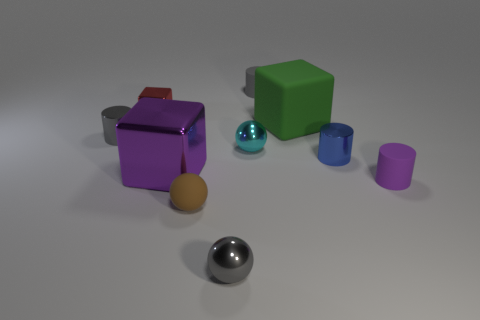There is another metal thing that is the same shape as the small red object; what is its size?
Offer a very short reply. Large. There is a purple rubber cylinder; does it have the same size as the green matte block that is right of the big purple metal block?
Your answer should be compact. No. The purple rubber thing that is right of the big metallic block has what shape?
Your answer should be very brief. Cylinder. The small shiny cylinder that is to the right of the metallic cylinder that is on the left side of the green matte thing is what color?
Offer a terse response. Blue. The other matte object that is the same shape as the tiny red thing is what color?
Your response must be concise. Green. What number of tiny metal balls are the same color as the big matte object?
Ensure brevity in your answer.  0. Is the color of the large metallic object the same as the small object that is on the right side of the small blue metallic thing?
Your answer should be compact. Yes. The gray object that is both behind the purple rubber cylinder and right of the big shiny thing has what shape?
Make the answer very short. Cylinder. There is a tiny gray cylinder on the right side of the tiny sphere that is behind the purple thing that is in front of the large purple metal block; what is its material?
Provide a succinct answer. Rubber. Is the number of blocks that are behind the small brown thing greater than the number of green matte objects on the left side of the large rubber object?
Your answer should be compact. Yes. 